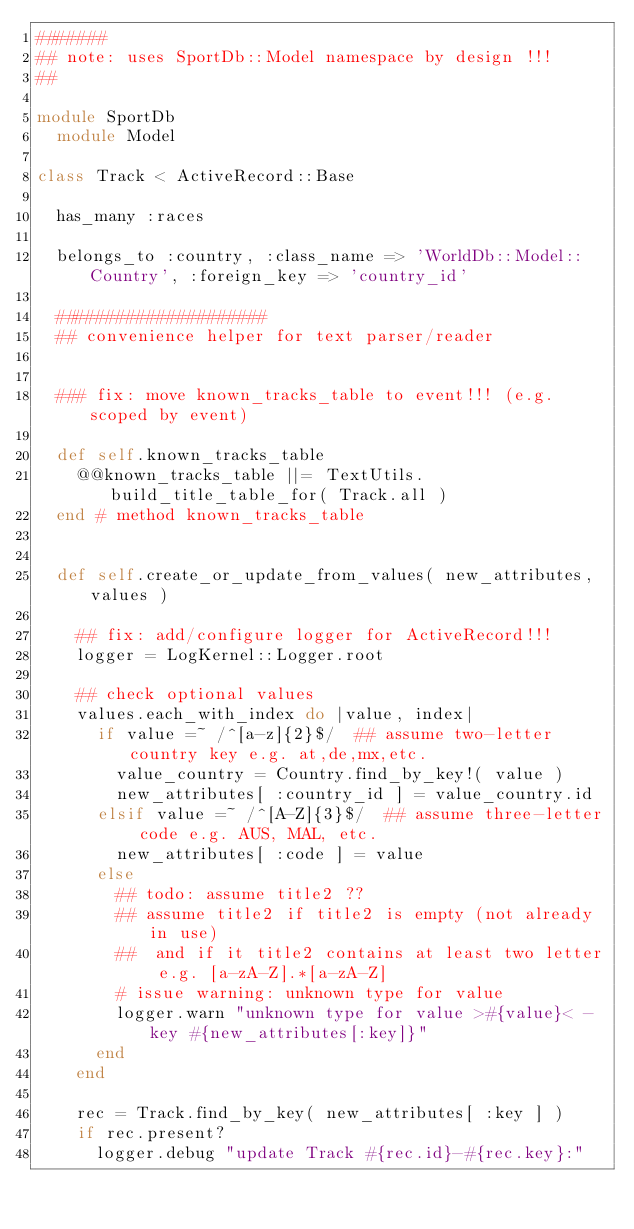<code> <loc_0><loc_0><loc_500><loc_500><_Ruby_>#######
## note: uses SportDb::Model namespace by design !!!
##

module SportDb
  module Model

class Track < ActiveRecord::Base

  has_many :races

  belongs_to :country, :class_name => 'WorldDb::Model::Country', :foreign_key => 'country_id'

  #####################
  ## convenience helper for text parser/reader


  ### fix: move known_tracks_table to event!!! (e.g. scoped by event)

  def self.known_tracks_table
    @@known_tracks_table ||= TextUtils.build_title_table_for( Track.all )
  end # method known_tracks_table


  def self.create_or_update_from_values( new_attributes, values )

    ## fix: add/configure logger for ActiveRecord!!!
    logger = LogKernel::Logger.root

    ## check optional values
    values.each_with_index do |value, index|
      if value =~ /^[a-z]{2}$/  ## assume two-letter country key e.g. at,de,mx,etc.
        value_country = Country.find_by_key!( value )
        new_attributes[ :country_id ] = value_country.id
      elsif value =~ /^[A-Z]{3}$/  ## assume three-letter code e.g. AUS, MAL, etc.
        new_attributes[ :code ] = value
      else
        ## todo: assume title2 ??
        ## assume title2 if title2 is empty (not already in use)
        ##  and if it title2 contains at least two letter e.g. [a-zA-Z].*[a-zA-Z]
        # issue warning: unknown type for value
        logger.warn "unknown type for value >#{value}< - key #{new_attributes[:key]}"
      end
    end

    rec = Track.find_by_key( new_attributes[ :key ] )
    if rec.present?
      logger.debug "update Track #{rec.id}-#{rec.key}:"</code> 